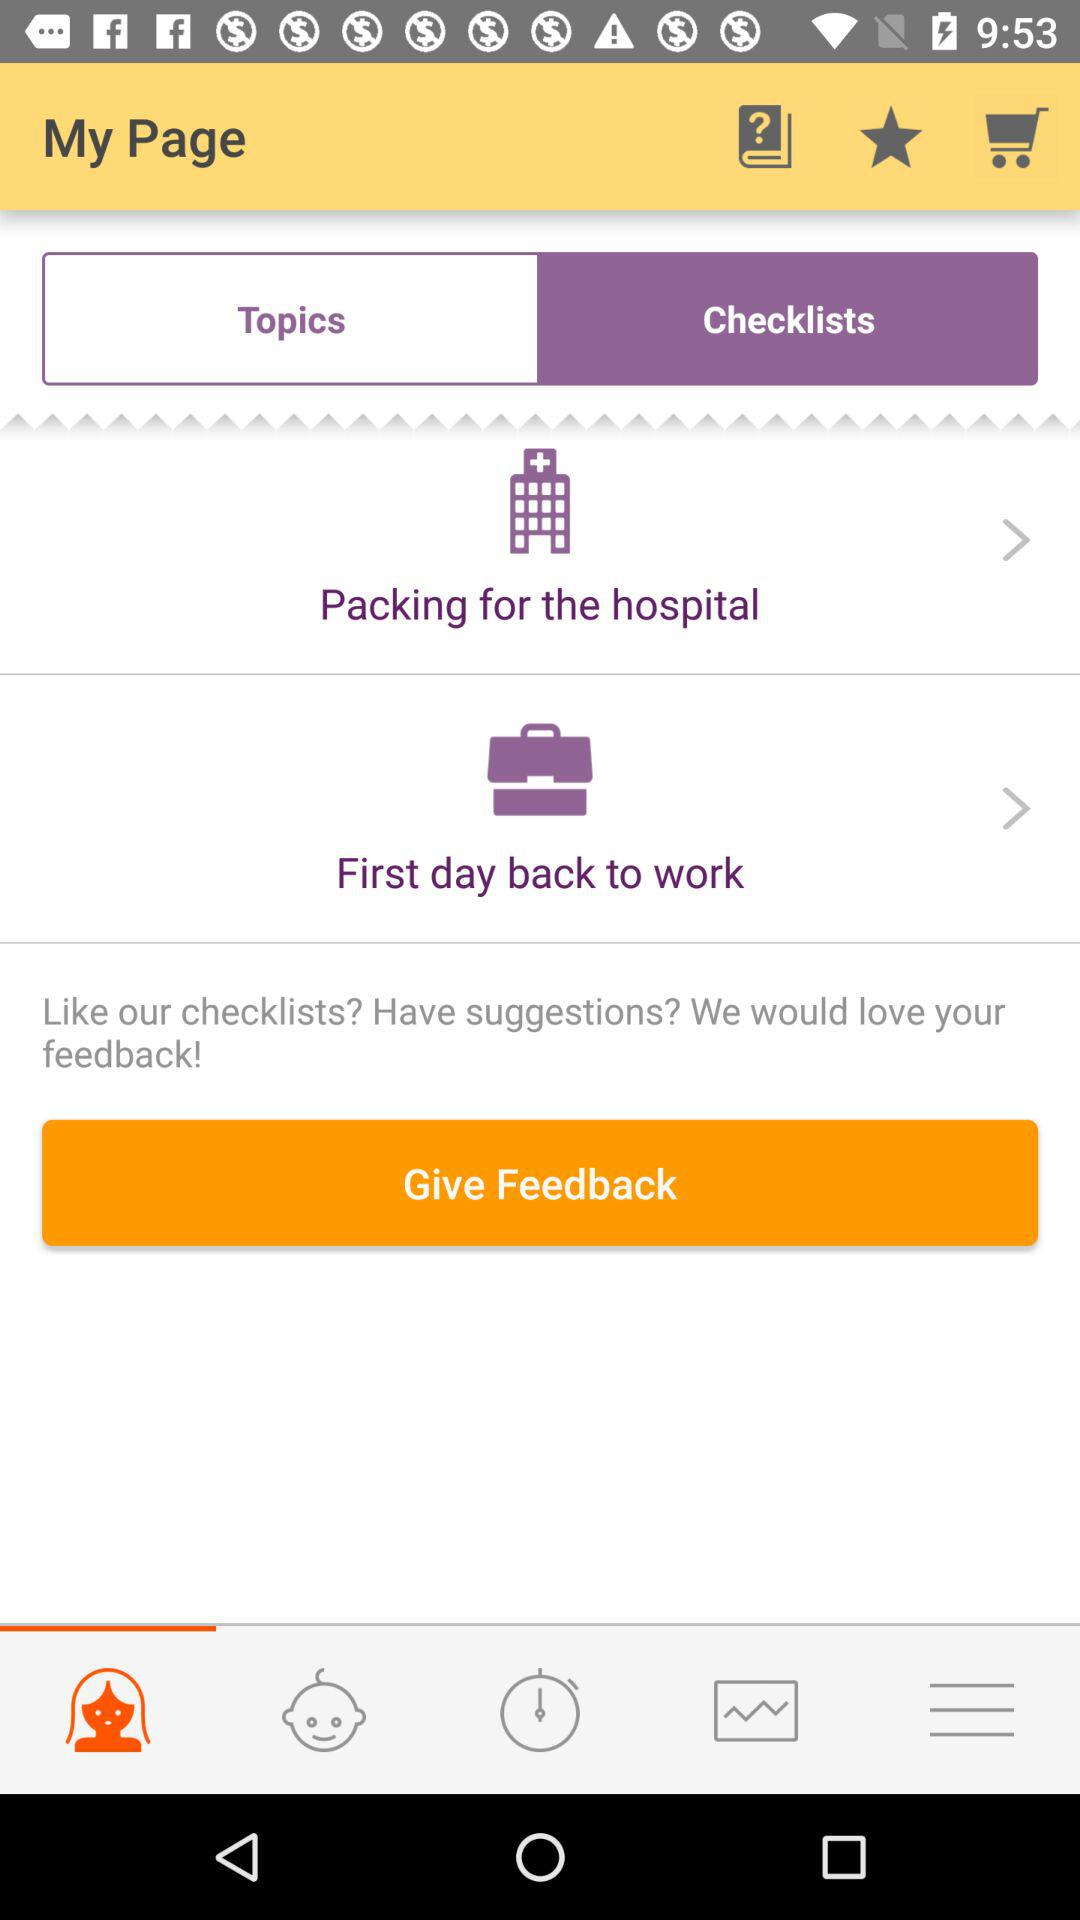Which tab has been selected? The tab that has been selected is "Checklists". 